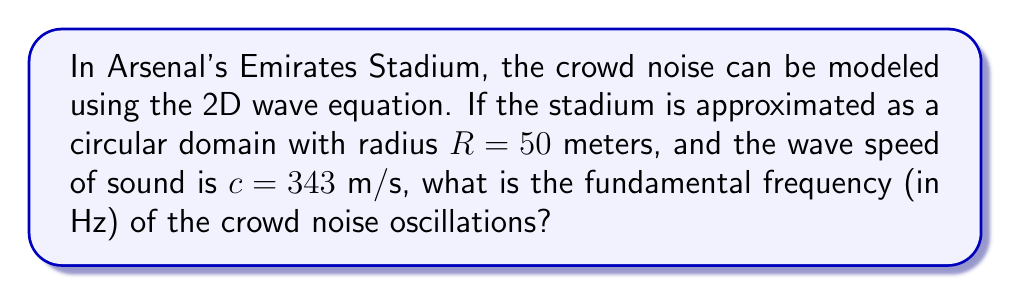Solve this math problem. To solve this problem, we'll follow these steps:

1) The 2D wave equation in polar coordinates for a circular domain is:

   $$\frac{\partial^2 u}{\partial t^2} = c^2 \left(\frac{\partial^2 u}{\partial r^2} + \frac{1}{r}\frac{\partial u}{\partial r}\right)$$

2) For a circular membrane with fixed boundary, the solution has the form:

   $$u(r,\theta,t) = J_0(\lambda r)(A\cos(\omega t) + B\sin(\omega t))$$

   where $J_0$ is the Bessel function of the first kind of order 0.

3) The boundary condition $u(R,\theta,t) = 0$ leads to:

   $$J_0(\lambda R) = 0$$

4) The smallest positive root of this equation is $\lambda R \approx 2.4048$.

5) The relationship between $\lambda$ and $\omega$ is:

   $$\omega = c\lambda$$

6) Substituting the values:

   $$\lambda = \frac{2.4048}{R} = \frac{2.4048}{50} = 0.048096 \text{ m}^{-1}$$

7) Calculate $\omega$:

   $$\omega = c\lambda = 343 \cdot 0.048096 = 16.4969 \text{ rad/s}$$

8) Convert angular frequency to regular frequency:

   $$f = \frac{\omega}{2\pi} = \frac{16.4969}{2\pi} \approx 2.6253 \text{ Hz}$$
Answer: 2.63 Hz 